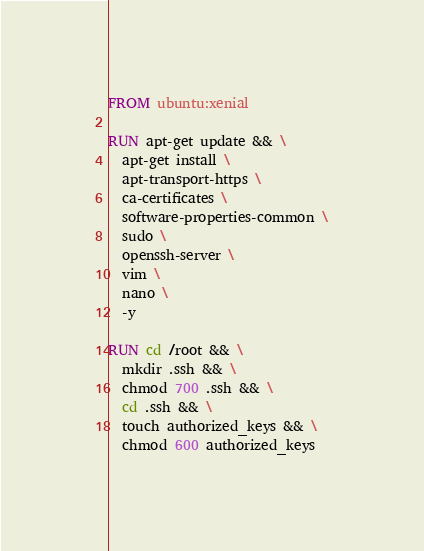<code> <loc_0><loc_0><loc_500><loc_500><_Dockerfile_>FROM ubuntu:xenial

RUN apt-get update && \
  apt-get install \
  apt-transport-https \
  ca-certificates \
  software-properties-common \
  sudo \
  openssh-server \
  vim \
  nano \
  -y

RUN cd /root && \
  mkdir .ssh && \
  chmod 700 .ssh && \
  cd .ssh && \
  touch authorized_keys && \
  chmod 600 authorized_keys
</code> 